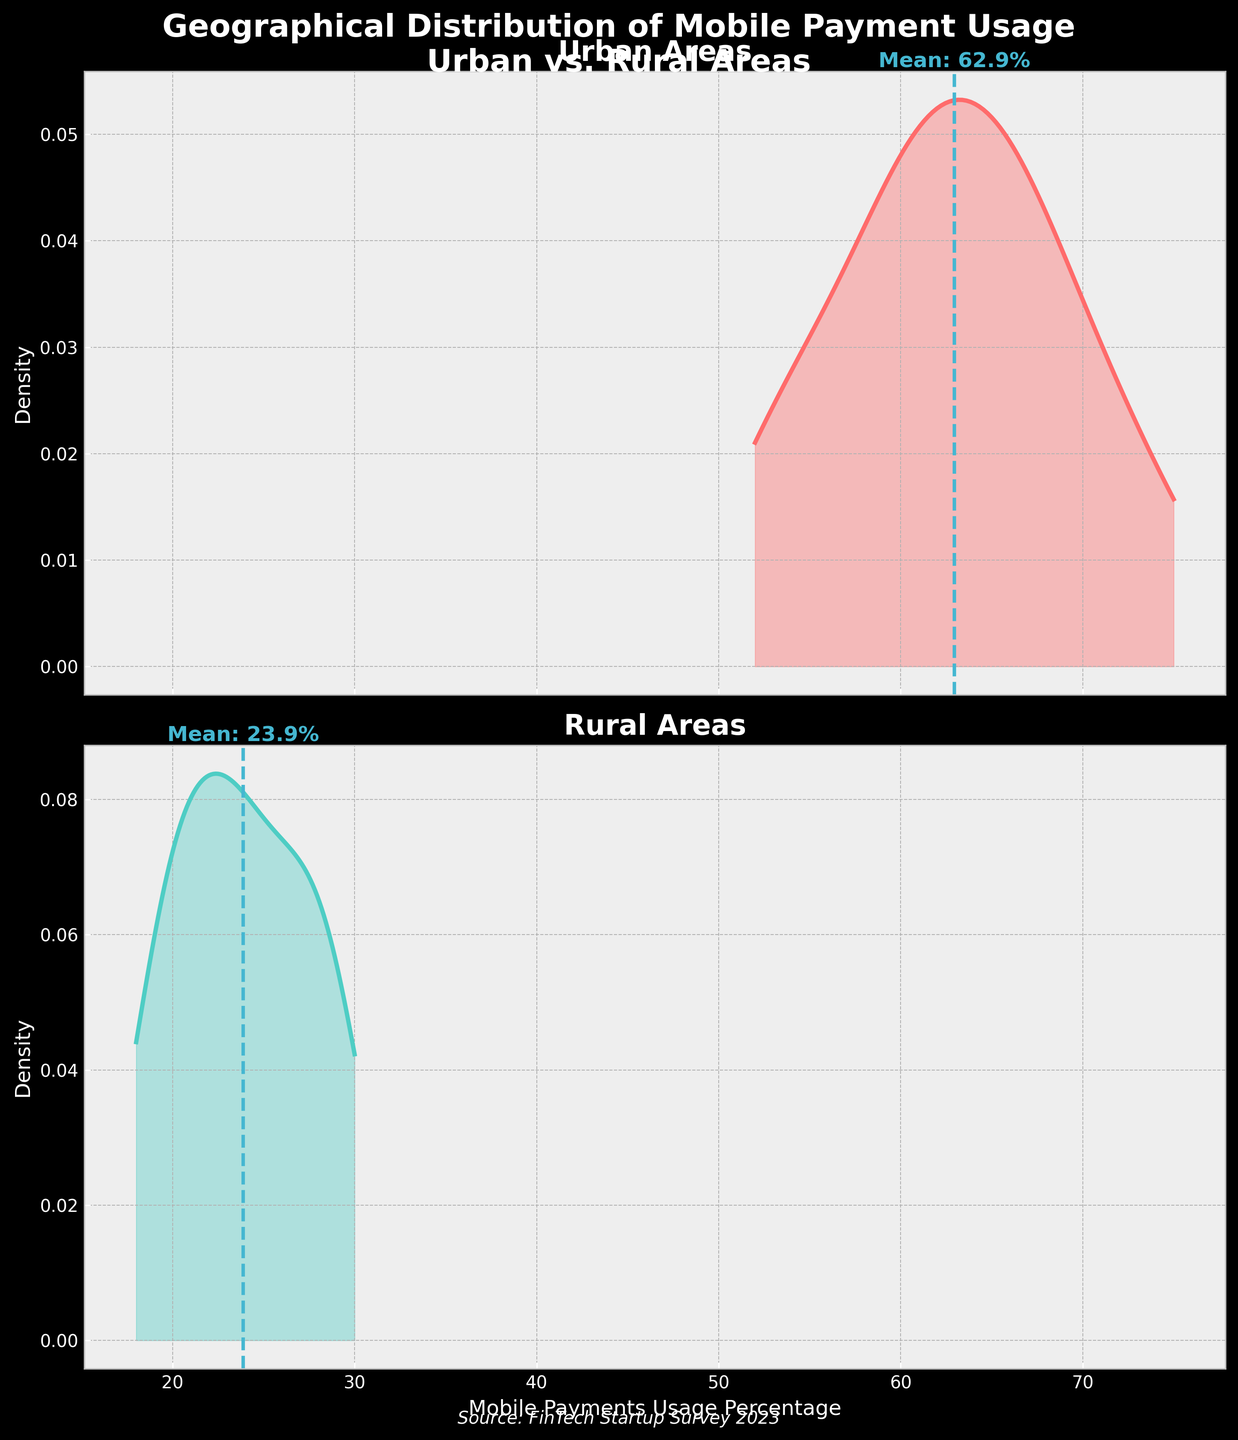what regions are compared in the figure? The title "Geographical Distribution of Mobile Payment Usage in Urban vs. Rural Areas" and the subplot titles ("Urban Areas" and "Rural Areas") indicate that the regions compared are urban and rural areas.
Answer: Urban and Rural what is the title of the smaller plot focused on urban areas? The subplot titles are displayed above each density plot. The title above the first subplot reads "Urban Areas."
Answer: Urban Areas How many density plots are shown in the figure? The figure contains two rows of subplots, with one density plot each, making a total of two density plots.
Answer: Two what color represents rural areas in the figure? The density plot for rural areas is filled and outlined by a teal color.
Answer: Teal What is the mean mobile payment usage percentage for urban areas? In the urban areas density plot, a vertical dashed line marks the mean percentage. This line is labeled near the top of the plot, which states “Mean: 63.4%.”
Answer: 63.4% what is the range of mobile payment usage percentages visualized in the density plots? Both density plots cover a common horizontal axis from about 18% to 75%.
Answer: 18% to 75% Which area has a wider range of mobile payment usage percentages? By observing the spread of the data in the density plots, the urban areas show a wider range (about 52% to 75%), whereas the rural areas show a narrower range (about 18% to 30%).
Answer: Urban Areas Are mobile payments more commonly used in urban areas or rural areas? The density plots indicate that the mobile payment usage percentage is significantly higher in urban areas with higher peaks and means compared to rural areas.
Answer: Urban Areas What is the approximate difference between the mean mobile payment usage percentages of urban and rural areas? The mean for urban areas is approximately 63.4% and for rural areas is approximately 23.9%. The difference is thus around 39.5%.
Answer: 39.5% What can be inferred about the mobile payment usage trend between urban and rural areas from the figure? The density plots suggest that mobile payment usage is substantially higher and more varied in urban areas, while in rural areas, it remains consistently low. This indicates more penetration and adoption of mobile payments in urban areas.
Answer: Higher and more varied in urban areas 